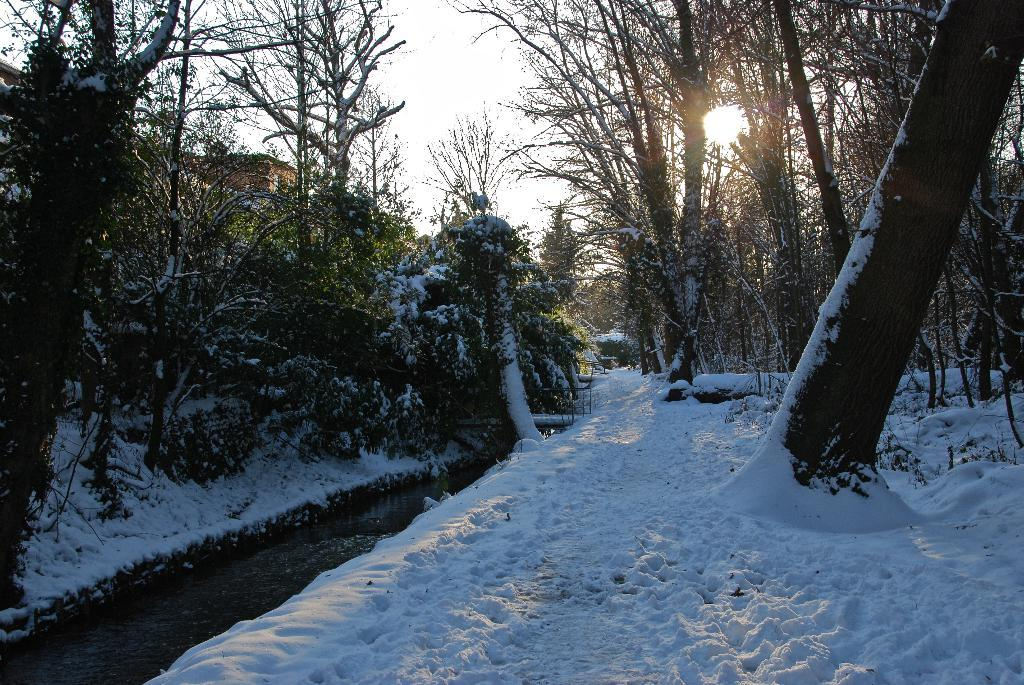What is the primary weather condition depicted in the image? There is snow in the image. What type of natural elements can be seen in the image? There are trees in the image. Can you identify any man-made structures in the image? Yes, there is a building in the image, located at the left back. What type of wheel is visible in the image? There is no wheel present in the image. How are the trees in the image being sorted? The trees in the image are not being sorted; they are simply depicted as part of the natural landscape. 